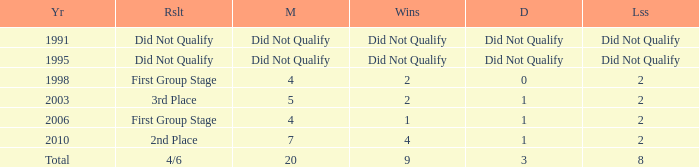What were the matches where the teams finished in the first group stage, in 1998? 4.0. 